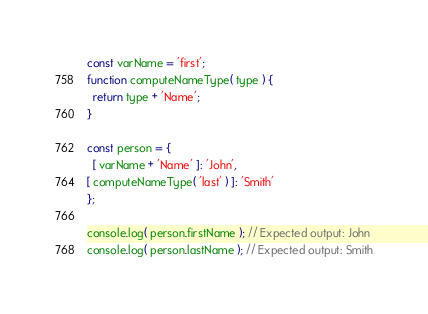<code> <loc_0><loc_0><loc_500><loc_500><_JavaScript_>const varName = 'first';
function computeNameType( type ) {
  return type + 'Name';
}

const person = {
  [ varName + 'Name' ]: 'John',
[ computeNameType( 'last' ) ]: 'Smith'
};

console.log( person.firstName ); // Expected output: John
console.log( person.lastName ); // Expected output: Smith
</code> 